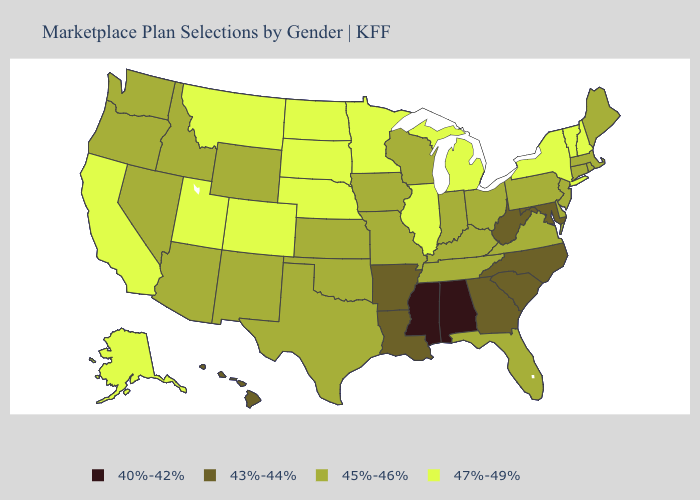Among the states that border Texas , which have the highest value?
Quick response, please. New Mexico, Oklahoma. Does Virginia have the lowest value in the USA?
Concise answer only. No. Name the states that have a value in the range 45%-46%?
Concise answer only. Arizona, Connecticut, Delaware, Florida, Idaho, Indiana, Iowa, Kansas, Kentucky, Maine, Massachusetts, Missouri, Nevada, New Jersey, New Mexico, Ohio, Oklahoma, Oregon, Pennsylvania, Rhode Island, Tennessee, Texas, Virginia, Washington, Wisconsin, Wyoming. Does the first symbol in the legend represent the smallest category?
Answer briefly. Yes. What is the value of Maine?
Write a very short answer. 45%-46%. Name the states that have a value in the range 40%-42%?
Short answer required. Alabama, Mississippi. What is the value of Ohio?
Keep it brief. 45%-46%. Name the states that have a value in the range 43%-44%?
Quick response, please. Arkansas, Georgia, Hawaii, Louisiana, Maryland, North Carolina, South Carolina, West Virginia. What is the value of Maryland?
Keep it brief. 43%-44%. What is the lowest value in states that border Iowa?
Be succinct. 45%-46%. Which states hav the highest value in the South?
Short answer required. Delaware, Florida, Kentucky, Oklahoma, Tennessee, Texas, Virginia. Which states have the lowest value in the USA?
Quick response, please. Alabama, Mississippi. What is the value of North Dakota?
Answer briefly. 47%-49%. What is the value of Connecticut?
Concise answer only. 45%-46%. Among the states that border Texas , does Louisiana have the lowest value?
Write a very short answer. Yes. 